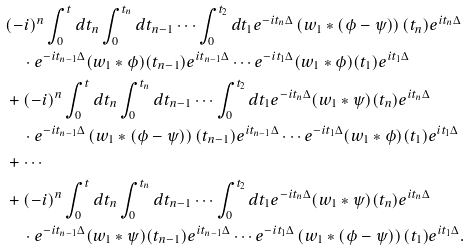Convert formula to latex. <formula><loc_0><loc_0><loc_500><loc_500>& ( - i ) ^ { n } \int _ { 0 } ^ { t } d t _ { n } \int _ { 0 } ^ { t _ { n } } d t _ { n - 1 } \cdots \int _ { 0 } ^ { t _ { 2 } } d t _ { 1 } e ^ { - i t _ { n } \Delta } \left ( w _ { 1 } * ( \phi - \psi ) \right ) ( t _ { n } ) e ^ { i t _ { n } \Delta } \\ & \quad \cdot e ^ { - i t _ { n - 1 } \Delta } ( w _ { 1 } * \phi ) ( t _ { n - 1 } ) e ^ { i t _ { n - 1 } \Delta } \cdots e ^ { - i t _ { 1 } \Delta } ( w _ { 1 } * \phi ) ( t _ { 1 } ) e ^ { i t _ { 1 } \Delta } \\ & + ( - i ) ^ { n } \int _ { 0 } ^ { t } d t _ { n } \int _ { 0 } ^ { t _ { n } } d t _ { n - 1 } \cdots \int _ { 0 } ^ { t _ { 2 } } d t _ { 1 } e ^ { - i t _ { n } \Delta } ( w _ { 1 } * \psi ) ( t _ { n } ) e ^ { i t _ { n } \Delta } \\ & \quad \cdot e ^ { - i t _ { n - 1 } \Delta } \left ( w _ { 1 } * ( \phi - \psi ) \right ) ( t _ { n - 1 } ) e ^ { i t _ { n - 1 } \Delta } \cdots e ^ { - i t _ { 1 } \Delta } ( w _ { 1 } * \phi ) ( t _ { 1 } ) e ^ { i t _ { 1 } \Delta } \\ & + \cdots \\ & + ( - i ) ^ { n } \int _ { 0 } ^ { t } d t _ { n } \int _ { 0 } ^ { t _ { n } } d t _ { n - 1 } \cdots \int _ { 0 } ^ { t _ { 2 } } d t _ { 1 } e ^ { - i t _ { n } \Delta } ( w _ { 1 } * \psi ) ( t _ { n } ) e ^ { i t _ { n } \Delta } \\ & \quad \cdot e ^ { - i t _ { n - 1 } \Delta } ( w _ { 1 } * \psi ) ( t _ { n - 1 } ) e ^ { i t _ { n - 1 } \Delta } \cdots e ^ { - i t _ { 1 } \Delta } \left ( w _ { 1 } * ( \phi - \psi ) \right ) ( t _ { 1 } ) e ^ { i t _ { 1 } \Delta } .</formula> 